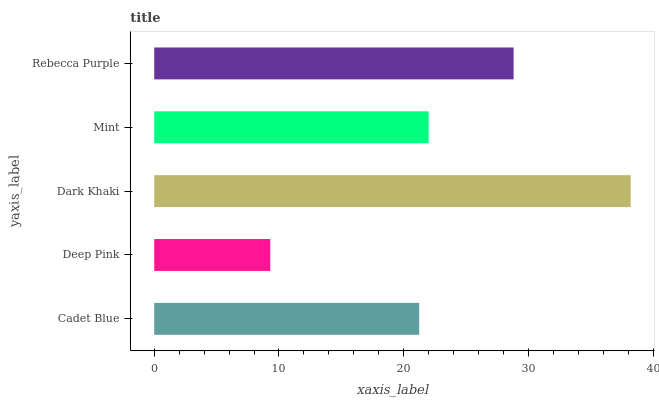Is Deep Pink the minimum?
Answer yes or no. Yes. Is Dark Khaki the maximum?
Answer yes or no. Yes. Is Dark Khaki the minimum?
Answer yes or no. No. Is Deep Pink the maximum?
Answer yes or no. No. Is Dark Khaki greater than Deep Pink?
Answer yes or no. Yes. Is Deep Pink less than Dark Khaki?
Answer yes or no. Yes. Is Deep Pink greater than Dark Khaki?
Answer yes or no. No. Is Dark Khaki less than Deep Pink?
Answer yes or no. No. Is Mint the high median?
Answer yes or no. Yes. Is Mint the low median?
Answer yes or no. Yes. Is Deep Pink the high median?
Answer yes or no. No. Is Cadet Blue the low median?
Answer yes or no. No. 